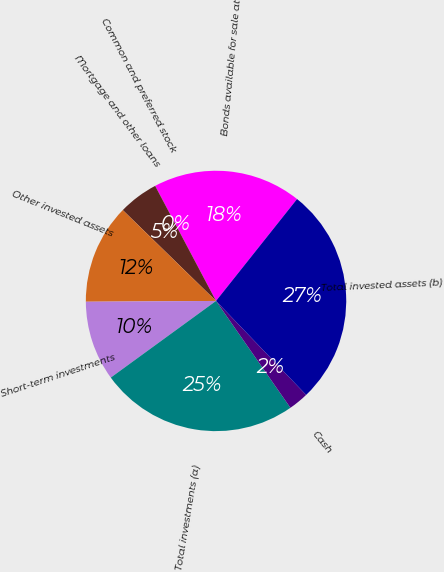<chart> <loc_0><loc_0><loc_500><loc_500><pie_chart><fcel>Bonds available for sale at<fcel>Common and preferred stock<fcel>Mortgage and other loans<fcel>Other invested assets<fcel>Short-term investments<fcel>Total investments (a)<fcel>Cash<fcel>Total invested assets (b)<nl><fcel>18.43%<fcel>0.01%<fcel>4.96%<fcel>12.39%<fcel>9.92%<fcel>24.66%<fcel>2.49%<fcel>27.14%<nl></chart> 